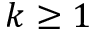Convert formula to latex. <formula><loc_0><loc_0><loc_500><loc_500>k \geq 1</formula> 